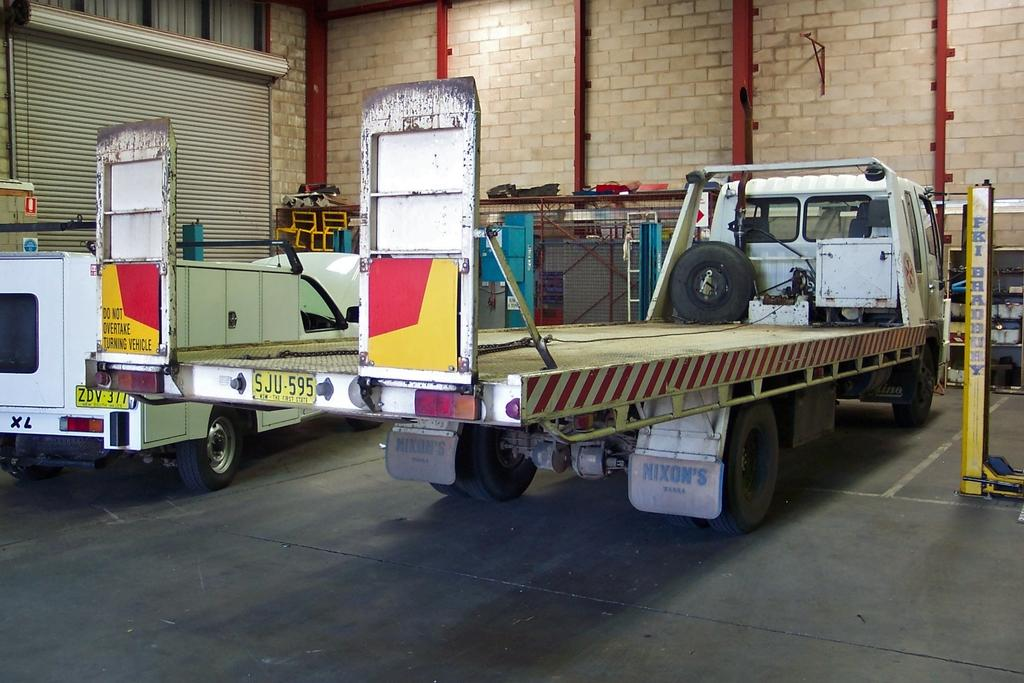What objects are on the floor in the image? There are vehicles on the floor in the image. What can be seen in the background of the image? In the background, there are rods, a rack, a mesh, and other objects. What type of window covering is present in the image? There are shutters in the image. What type of structure is visible in the image? There is a wall in the image. What type of dirt can be seen on the vehicles in the image? There is no dirt visible on the vehicles in the image. What type of industry is depicted in the image? The image does not depict any industry; it shows vehicles, rods, a rack, a mesh, shutters, and a wall. 